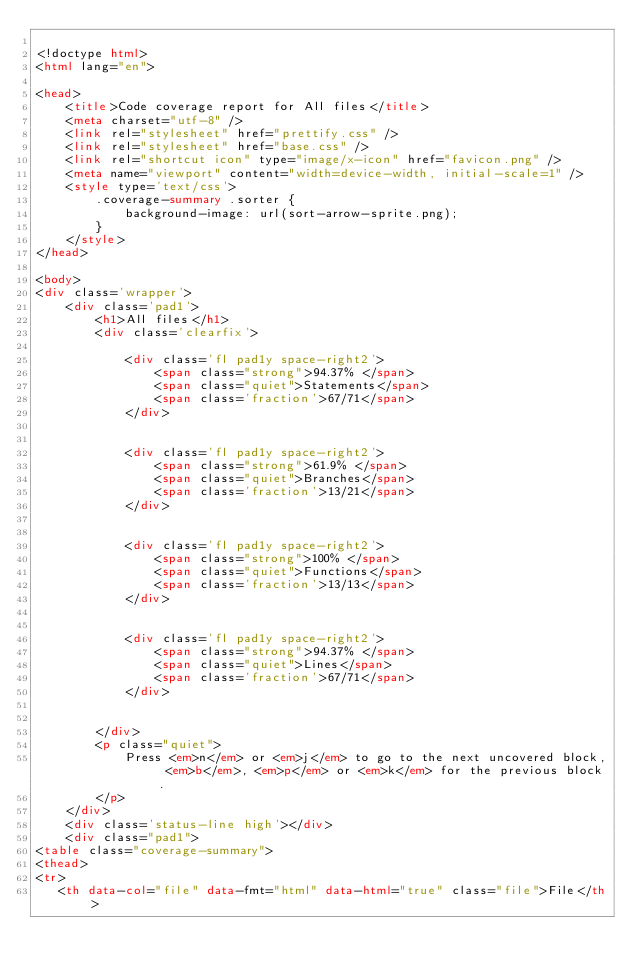Convert code to text. <code><loc_0><loc_0><loc_500><loc_500><_HTML_>
<!doctype html>
<html lang="en">

<head>
    <title>Code coverage report for All files</title>
    <meta charset="utf-8" />
    <link rel="stylesheet" href="prettify.css" />
    <link rel="stylesheet" href="base.css" />
    <link rel="shortcut icon" type="image/x-icon" href="favicon.png" />
    <meta name="viewport" content="width=device-width, initial-scale=1" />
    <style type='text/css'>
        .coverage-summary .sorter {
            background-image: url(sort-arrow-sprite.png);
        }
    </style>
</head>
    
<body>
<div class='wrapper'>
    <div class='pad1'>
        <h1>All files</h1>
        <div class='clearfix'>
            
            <div class='fl pad1y space-right2'>
                <span class="strong">94.37% </span>
                <span class="quiet">Statements</span>
                <span class='fraction'>67/71</span>
            </div>
        
            
            <div class='fl pad1y space-right2'>
                <span class="strong">61.9% </span>
                <span class="quiet">Branches</span>
                <span class='fraction'>13/21</span>
            </div>
        
            
            <div class='fl pad1y space-right2'>
                <span class="strong">100% </span>
                <span class="quiet">Functions</span>
                <span class='fraction'>13/13</span>
            </div>
        
            
            <div class='fl pad1y space-right2'>
                <span class="strong">94.37% </span>
                <span class="quiet">Lines</span>
                <span class='fraction'>67/71</span>
            </div>
        
            
        </div>
        <p class="quiet">
            Press <em>n</em> or <em>j</em> to go to the next uncovered block, <em>b</em>, <em>p</em> or <em>k</em> for the previous block.
        </p>
    </div>
    <div class='status-line high'></div>
    <div class="pad1">
<table class="coverage-summary">
<thead>
<tr>
   <th data-col="file" data-fmt="html" data-html="true" class="file">File</th></code> 